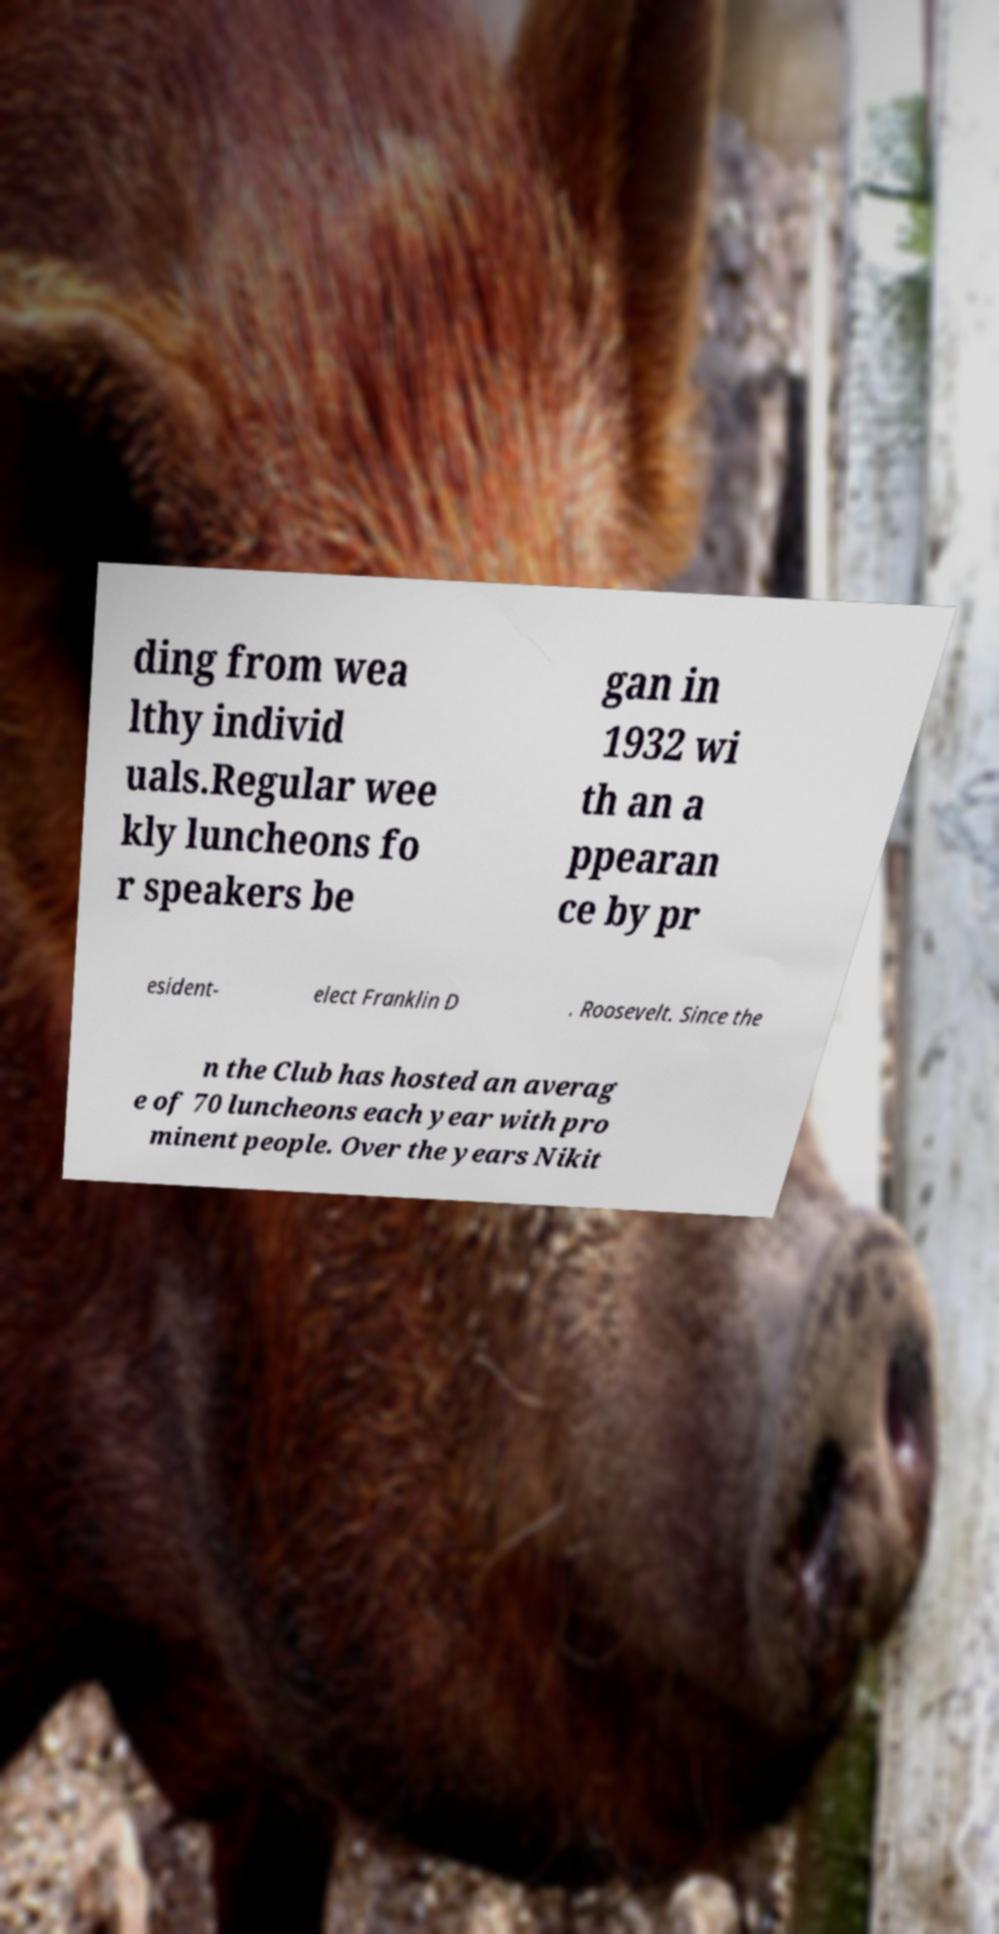I need the written content from this picture converted into text. Can you do that? ding from wea lthy individ uals.Regular wee kly luncheons fo r speakers be gan in 1932 wi th an a ppearan ce by pr esident- elect Franklin D . Roosevelt. Since the n the Club has hosted an averag e of 70 luncheons each year with pro minent people. Over the years Nikit 